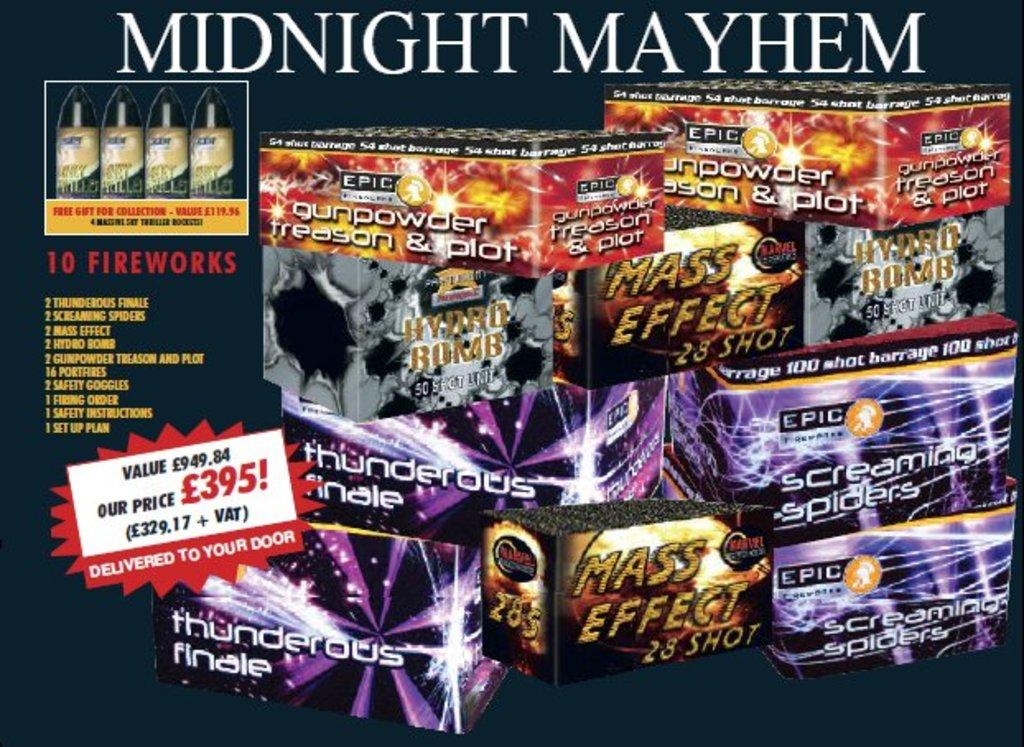<image>
Provide a brief description of the given image. a sign that says 'midnight mayhem' at the top 